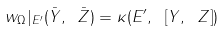Convert formula to latex. <formula><loc_0><loc_0><loc_500><loc_500>w _ { \Omega } | _ { E ^ { \prime } } ( \bar { Y } , \ \bar { Z } ) = \kappa ( E ^ { \prime } , \ [ Y , \ Z ] )</formula> 